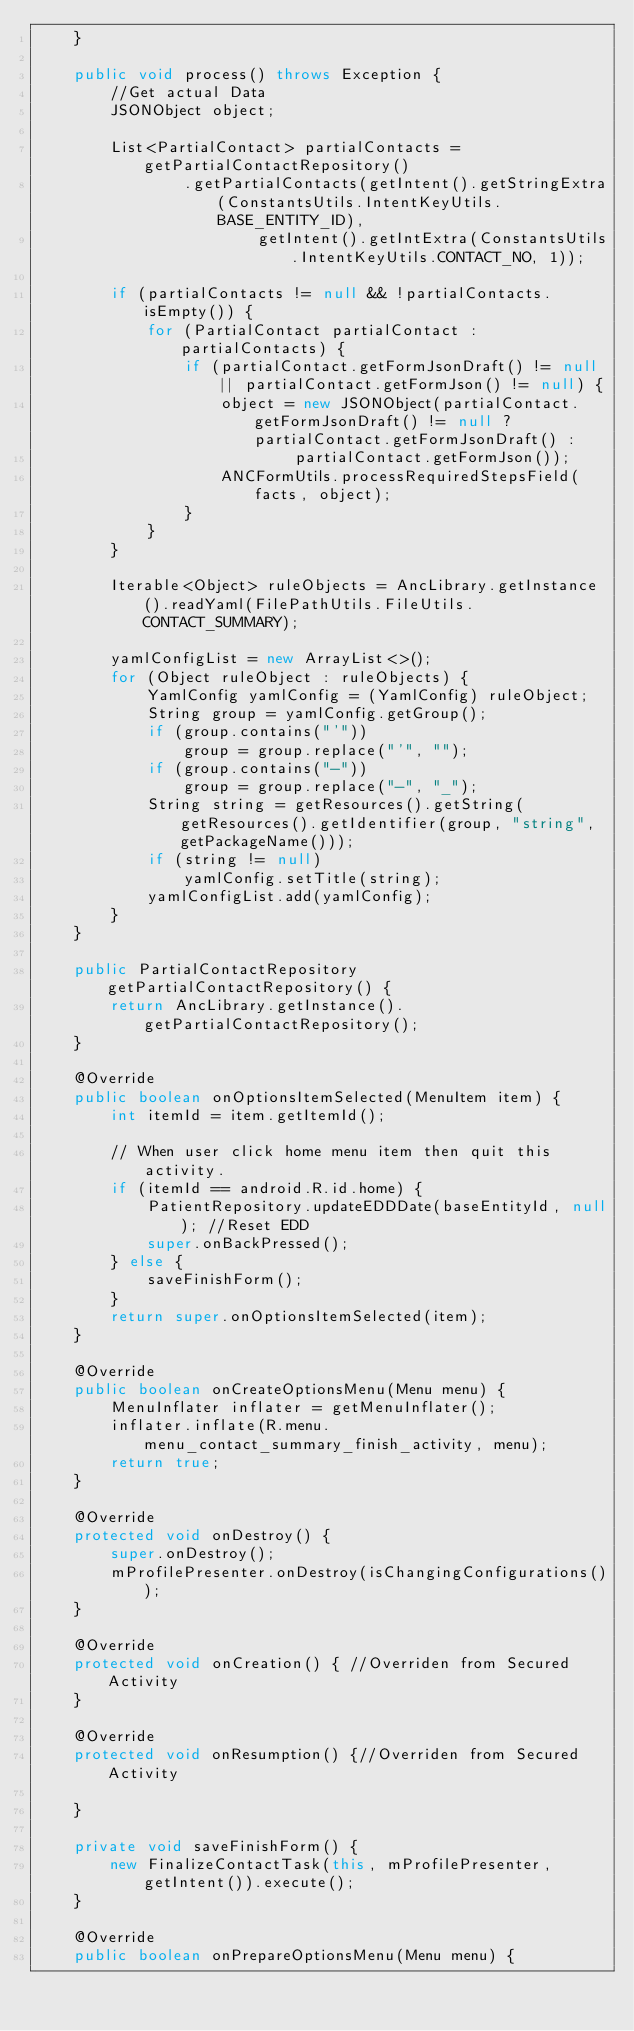Convert code to text. <code><loc_0><loc_0><loc_500><loc_500><_Java_>    }

    public void process() throws Exception {
        //Get actual Data
        JSONObject object;

        List<PartialContact> partialContacts = getPartialContactRepository()
                .getPartialContacts(getIntent().getStringExtra(ConstantsUtils.IntentKeyUtils.BASE_ENTITY_ID),
                        getIntent().getIntExtra(ConstantsUtils.IntentKeyUtils.CONTACT_NO, 1));

        if (partialContacts != null && !partialContacts.isEmpty()) {
            for (PartialContact partialContact : partialContacts) {
                if (partialContact.getFormJsonDraft() != null || partialContact.getFormJson() != null) {
                    object = new JSONObject(partialContact.getFormJsonDraft() != null ? partialContact.getFormJsonDraft() :
                            partialContact.getFormJson());
                    ANCFormUtils.processRequiredStepsField(facts, object);
                }
            }
        }

        Iterable<Object> ruleObjects = AncLibrary.getInstance().readYaml(FilePathUtils.FileUtils.CONTACT_SUMMARY);

        yamlConfigList = new ArrayList<>();
        for (Object ruleObject : ruleObjects) {
            YamlConfig yamlConfig = (YamlConfig) ruleObject;
            String group = yamlConfig.getGroup();
            if (group.contains("'"))
                group = group.replace("'", "");
            if (group.contains("-"))
                group = group.replace("-", "_");
            String string = getResources().getString(getResources().getIdentifier(group, "string", getPackageName()));
            if (string != null)
                yamlConfig.setTitle(string);
            yamlConfigList.add(yamlConfig);
        }
    }

    public PartialContactRepository getPartialContactRepository() {
        return AncLibrary.getInstance().getPartialContactRepository();
    }

    @Override
    public boolean onOptionsItemSelected(MenuItem item) {
        int itemId = item.getItemId();

        // When user click home menu item then quit this activity.
        if (itemId == android.R.id.home) {
            PatientRepository.updateEDDDate(baseEntityId, null); //Reset EDD
            super.onBackPressed();
        } else {
            saveFinishForm();
        }
        return super.onOptionsItemSelected(item);
    }

    @Override
    public boolean onCreateOptionsMenu(Menu menu) {
        MenuInflater inflater = getMenuInflater();
        inflater.inflate(R.menu.menu_contact_summary_finish_activity, menu);
        return true;
    }

    @Override
    protected void onDestroy() {
        super.onDestroy();
        mProfilePresenter.onDestroy(isChangingConfigurations());
    }

    @Override
    protected void onCreation() { //Overriden from Secured Activity
    }

    @Override
    protected void onResumption() {//Overriden from Secured Activity

    }

    private void saveFinishForm() {
        new FinalizeContactTask(this, mProfilePresenter, getIntent()).execute();
    }

    @Override
    public boolean onPrepareOptionsMenu(Menu menu) {</code> 